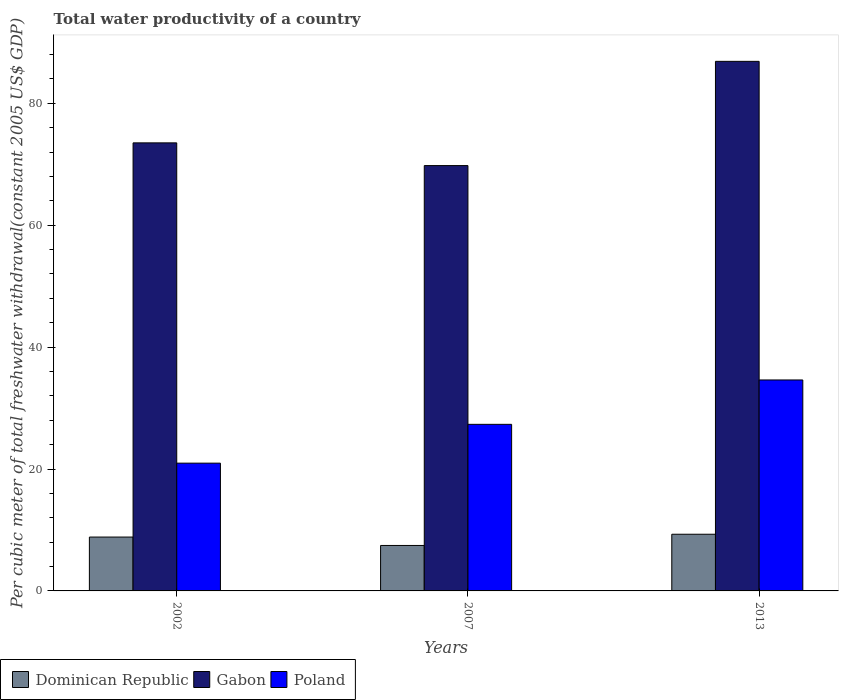How many groups of bars are there?
Offer a terse response. 3. What is the label of the 1st group of bars from the left?
Provide a short and direct response. 2002. What is the total water productivity in Dominican Republic in 2013?
Give a very brief answer. 9.3. Across all years, what is the maximum total water productivity in Gabon?
Give a very brief answer. 86.88. Across all years, what is the minimum total water productivity in Gabon?
Give a very brief answer. 69.78. In which year was the total water productivity in Dominican Republic maximum?
Your answer should be compact. 2013. In which year was the total water productivity in Dominican Republic minimum?
Provide a short and direct response. 2007. What is the total total water productivity in Dominican Republic in the graph?
Keep it short and to the point. 25.59. What is the difference between the total water productivity in Poland in 2002 and that in 2007?
Provide a short and direct response. -6.37. What is the difference between the total water productivity in Dominican Republic in 2007 and the total water productivity in Gabon in 2013?
Offer a terse response. -79.42. What is the average total water productivity in Poland per year?
Provide a succinct answer. 27.63. In the year 2007, what is the difference between the total water productivity in Dominican Republic and total water productivity in Poland?
Offer a very short reply. -19.87. In how many years, is the total water productivity in Poland greater than 56 US$?
Your answer should be compact. 0. What is the ratio of the total water productivity in Gabon in 2007 to that in 2013?
Your response must be concise. 0.8. Is the total water productivity in Dominican Republic in 2002 less than that in 2013?
Your response must be concise. Yes. What is the difference between the highest and the second highest total water productivity in Dominican Republic?
Provide a short and direct response. 0.46. What is the difference between the highest and the lowest total water productivity in Poland?
Provide a succinct answer. 13.65. In how many years, is the total water productivity in Poland greater than the average total water productivity in Poland taken over all years?
Ensure brevity in your answer.  1. Is the sum of the total water productivity in Gabon in 2002 and 2013 greater than the maximum total water productivity in Poland across all years?
Your answer should be very brief. Yes. What does the 3rd bar from the left in 2002 represents?
Provide a short and direct response. Poland. Is it the case that in every year, the sum of the total water productivity in Dominican Republic and total water productivity in Poland is greater than the total water productivity in Gabon?
Keep it short and to the point. No. Does the graph contain grids?
Your answer should be very brief. No. How many legend labels are there?
Your response must be concise. 3. How are the legend labels stacked?
Make the answer very short. Horizontal. What is the title of the graph?
Your answer should be compact. Total water productivity of a country. Does "Equatorial Guinea" appear as one of the legend labels in the graph?
Your response must be concise. No. What is the label or title of the Y-axis?
Offer a very short reply. Per cubic meter of total freshwater withdrawal(constant 2005 US$ GDP). What is the Per cubic meter of total freshwater withdrawal(constant 2005 US$ GDP) in Dominican Republic in 2002?
Give a very brief answer. 8.84. What is the Per cubic meter of total freshwater withdrawal(constant 2005 US$ GDP) of Gabon in 2002?
Make the answer very short. 73.51. What is the Per cubic meter of total freshwater withdrawal(constant 2005 US$ GDP) in Poland in 2002?
Your response must be concise. 20.96. What is the Per cubic meter of total freshwater withdrawal(constant 2005 US$ GDP) of Dominican Republic in 2007?
Your response must be concise. 7.46. What is the Per cubic meter of total freshwater withdrawal(constant 2005 US$ GDP) in Gabon in 2007?
Provide a succinct answer. 69.78. What is the Per cubic meter of total freshwater withdrawal(constant 2005 US$ GDP) of Poland in 2007?
Keep it short and to the point. 27.33. What is the Per cubic meter of total freshwater withdrawal(constant 2005 US$ GDP) of Dominican Republic in 2013?
Keep it short and to the point. 9.3. What is the Per cubic meter of total freshwater withdrawal(constant 2005 US$ GDP) of Gabon in 2013?
Your answer should be compact. 86.88. What is the Per cubic meter of total freshwater withdrawal(constant 2005 US$ GDP) of Poland in 2013?
Provide a short and direct response. 34.61. Across all years, what is the maximum Per cubic meter of total freshwater withdrawal(constant 2005 US$ GDP) in Dominican Republic?
Provide a short and direct response. 9.3. Across all years, what is the maximum Per cubic meter of total freshwater withdrawal(constant 2005 US$ GDP) of Gabon?
Make the answer very short. 86.88. Across all years, what is the maximum Per cubic meter of total freshwater withdrawal(constant 2005 US$ GDP) of Poland?
Provide a short and direct response. 34.61. Across all years, what is the minimum Per cubic meter of total freshwater withdrawal(constant 2005 US$ GDP) in Dominican Republic?
Provide a succinct answer. 7.46. Across all years, what is the minimum Per cubic meter of total freshwater withdrawal(constant 2005 US$ GDP) in Gabon?
Give a very brief answer. 69.78. Across all years, what is the minimum Per cubic meter of total freshwater withdrawal(constant 2005 US$ GDP) of Poland?
Make the answer very short. 20.96. What is the total Per cubic meter of total freshwater withdrawal(constant 2005 US$ GDP) of Dominican Republic in the graph?
Your response must be concise. 25.59. What is the total Per cubic meter of total freshwater withdrawal(constant 2005 US$ GDP) of Gabon in the graph?
Offer a terse response. 230.16. What is the total Per cubic meter of total freshwater withdrawal(constant 2005 US$ GDP) of Poland in the graph?
Your answer should be very brief. 82.9. What is the difference between the Per cubic meter of total freshwater withdrawal(constant 2005 US$ GDP) in Dominican Republic in 2002 and that in 2007?
Make the answer very short. 1.38. What is the difference between the Per cubic meter of total freshwater withdrawal(constant 2005 US$ GDP) in Gabon in 2002 and that in 2007?
Offer a very short reply. 3.73. What is the difference between the Per cubic meter of total freshwater withdrawal(constant 2005 US$ GDP) of Poland in 2002 and that in 2007?
Your answer should be compact. -6.37. What is the difference between the Per cubic meter of total freshwater withdrawal(constant 2005 US$ GDP) in Dominican Republic in 2002 and that in 2013?
Your answer should be very brief. -0.46. What is the difference between the Per cubic meter of total freshwater withdrawal(constant 2005 US$ GDP) of Gabon in 2002 and that in 2013?
Your answer should be very brief. -13.37. What is the difference between the Per cubic meter of total freshwater withdrawal(constant 2005 US$ GDP) of Poland in 2002 and that in 2013?
Your answer should be compact. -13.65. What is the difference between the Per cubic meter of total freshwater withdrawal(constant 2005 US$ GDP) in Dominican Republic in 2007 and that in 2013?
Offer a terse response. -1.84. What is the difference between the Per cubic meter of total freshwater withdrawal(constant 2005 US$ GDP) of Gabon in 2007 and that in 2013?
Make the answer very short. -17.1. What is the difference between the Per cubic meter of total freshwater withdrawal(constant 2005 US$ GDP) in Poland in 2007 and that in 2013?
Your answer should be very brief. -7.28. What is the difference between the Per cubic meter of total freshwater withdrawal(constant 2005 US$ GDP) of Dominican Republic in 2002 and the Per cubic meter of total freshwater withdrawal(constant 2005 US$ GDP) of Gabon in 2007?
Provide a succinct answer. -60.94. What is the difference between the Per cubic meter of total freshwater withdrawal(constant 2005 US$ GDP) of Dominican Republic in 2002 and the Per cubic meter of total freshwater withdrawal(constant 2005 US$ GDP) of Poland in 2007?
Your response must be concise. -18.49. What is the difference between the Per cubic meter of total freshwater withdrawal(constant 2005 US$ GDP) of Gabon in 2002 and the Per cubic meter of total freshwater withdrawal(constant 2005 US$ GDP) of Poland in 2007?
Your answer should be compact. 46.18. What is the difference between the Per cubic meter of total freshwater withdrawal(constant 2005 US$ GDP) in Dominican Republic in 2002 and the Per cubic meter of total freshwater withdrawal(constant 2005 US$ GDP) in Gabon in 2013?
Offer a very short reply. -78.04. What is the difference between the Per cubic meter of total freshwater withdrawal(constant 2005 US$ GDP) of Dominican Republic in 2002 and the Per cubic meter of total freshwater withdrawal(constant 2005 US$ GDP) of Poland in 2013?
Your answer should be compact. -25.77. What is the difference between the Per cubic meter of total freshwater withdrawal(constant 2005 US$ GDP) of Gabon in 2002 and the Per cubic meter of total freshwater withdrawal(constant 2005 US$ GDP) of Poland in 2013?
Your response must be concise. 38.9. What is the difference between the Per cubic meter of total freshwater withdrawal(constant 2005 US$ GDP) of Dominican Republic in 2007 and the Per cubic meter of total freshwater withdrawal(constant 2005 US$ GDP) of Gabon in 2013?
Offer a terse response. -79.42. What is the difference between the Per cubic meter of total freshwater withdrawal(constant 2005 US$ GDP) of Dominican Republic in 2007 and the Per cubic meter of total freshwater withdrawal(constant 2005 US$ GDP) of Poland in 2013?
Your response must be concise. -27.15. What is the difference between the Per cubic meter of total freshwater withdrawal(constant 2005 US$ GDP) of Gabon in 2007 and the Per cubic meter of total freshwater withdrawal(constant 2005 US$ GDP) of Poland in 2013?
Give a very brief answer. 35.17. What is the average Per cubic meter of total freshwater withdrawal(constant 2005 US$ GDP) in Dominican Republic per year?
Keep it short and to the point. 8.53. What is the average Per cubic meter of total freshwater withdrawal(constant 2005 US$ GDP) in Gabon per year?
Provide a succinct answer. 76.72. What is the average Per cubic meter of total freshwater withdrawal(constant 2005 US$ GDP) in Poland per year?
Provide a succinct answer. 27.63. In the year 2002, what is the difference between the Per cubic meter of total freshwater withdrawal(constant 2005 US$ GDP) of Dominican Republic and Per cubic meter of total freshwater withdrawal(constant 2005 US$ GDP) of Gabon?
Your response must be concise. -64.67. In the year 2002, what is the difference between the Per cubic meter of total freshwater withdrawal(constant 2005 US$ GDP) in Dominican Republic and Per cubic meter of total freshwater withdrawal(constant 2005 US$ GDP) in Poland?
Keep it short and to the point. -12.13. In the year 2002, what is the difference between the Per cubic meter of total freshwater withdrawal(constant 2005 US$ GDP) of Gabon and Per cubic meter of total freshwater withdrawal(constant 2005 US$ GDP) of Poland?
Your answer should be compact. 52.54. In the year 2007, what is the difference between the Per cubic meter of total freshwater withdrawal(constant 2005 US$ GDP) of Dominican Republic and Per cubic meter of total freshwater withdrawal(constant 2005 US$ GDP) of Gabon?
Make the answer very short. -62.32. In the year 2007, what is the difference between the Per cubic meter of total freshwater withdrawal(constant 2005 US$ GDP) of Dominican Republic and Per cubic meter of total freshwater withdrawal(constant 2005 US$ GDP) of Poland?
Give a very brief answer. -19.87. In the year 2007, what is the difference between the Per cubic meter of total freshwater withdrawal(constant 2005 US$ GDP) of Gabon and Per cubic meter of total freshwater withdrawal(constant 2005 US$ GDP) of Poland?
Keep it short and to the point. 42.45. In the year 2013, what is the difference between the Per cubic meter of total freshwater withdrawal(constant 2005 US$ GDP) of Dominican Republic and Per cubic meter of total freshwater withdrawal(constant 2005 US$ GDP) of Gabon?
Make the answer very short. -77.58. In the year 2013, what is the difference between the Per cubic meter of total freshwater withdrawal(constant 2005 US$ GDP) of Dominican Republic and Per cubic meter of total freshwater withdrawal(constant 2005 US$ GDP) of Poland?
Offer a terse response. -25.31. In the year 2013, what is the difference between the Per cubic meter of total freshwater withdrawal(constant 2005 US$ GDP) of Gabon and Per cubic meter of total freshwater withdrawal(constant 2005 US$ GDP) of Poland?
Keep it short and to the point. 52.27. What is the ratio of the Per cubic meter of total freshwater withdrawal(constant 2005 US$ GDP) in Dominican Republic in 2002 to that in 2007?
Keep it short and to the point. 1.18. What is the ratio of the Per cubic meter of total freshwater withdrawal(constant 2005 US$ GDP) of Gabon in 2002 to that in 2007?
Your response must be concise. 1.05. What is the ratio of the Per cubic meter of total freshwater withdrawal(constant 2005 US$ GDP) of Poland in 2002 to that in 2007?
Give a very brief answer. 0.77. What is the ratio of the Per cubic meter of total freshwater withdrawal(constant 2005 US$ GDP) in Dominican Republic in 2002 to that in 2013?
Offer a very short reply. 0.95. What is the ratio of the Per cubic meter of total freshwater withdrawal(constant 2005 US$ GDP) in Gabon in 2002 to that in 2013?
Make the answer very short. 0.85. What is the ratio of the Per cubic meter of total freshwater withdrawal(constant 2005 US$ GDP) of Poland in 2002 to that in 2013?
Keep it short and to the point. 0.61. What is the ratio of the Per cubic meter of total freshwater withdrawal(constant 2005 US$ GDP) in Dominican Republic in 2007 to that in 2013?
Give a very brief answer. 0.8. What is the ratio of the Per cubic meter of total freshwater withdrawal(constant 2005 US$ GDP) in Gabon in 2007 to that in 2013?
Offer a very short reply. 0.8. What is the ratio of the Per cubic meter of total freshwater withdrawal(constant 2005 US$ GDP) of Poland in 2007 to that in 2013?
Keep it short and to the point. 0.79. What is the difference between the highest and the second highest Per cubic meter of total freshwater withdrawal(constant 2005 US$ GDP) of Dominican Republic?
Give a very brief answer. 0.46. What is the difference between the highest and the second highest Per cubic meter of total freshwater withdrawal(constant 2005 US$ GDP) in Gabon?
Provide a succinct answer. 13.37. What is the difference between the highest and the second highest Per cubic meter of total freshwater withdrawal(constant 2005 US$ GDP) of Poland?
Provide a short and direct response. 7.28. What is the difference between the highest and the lowest Per cubic meter of total freshwater withdrawal(constant 2005 US$ GDP) of Dominican Republic?
Your answer should be very brief. 1.84. What is the difference between the highest and the lowest Per cubic meter of total freshwater withdrawal(constant 2005 US$ GDP) in Gabon?
Your response must be concise. 17.1. What is the difference between the highest and the lowest Per cubic meter of total freshwater withdrawal(constant 2005 US$ GDP) in Poland?
Offer a terse response. 13.65. 